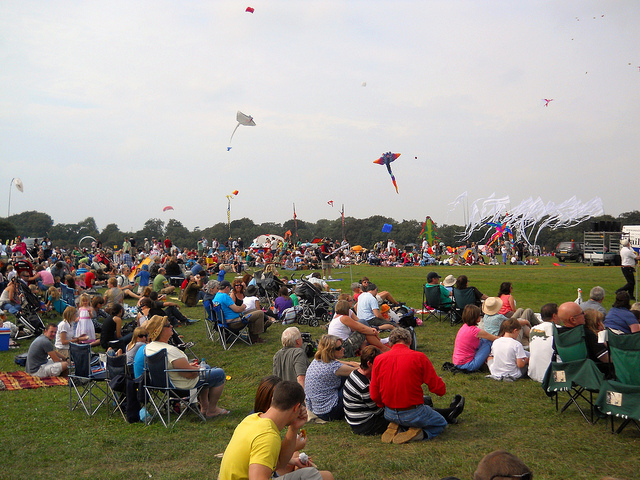Why are there more people than kites? The reason there are more people than kites in the image is likely that this gathering is not just about flying kites but also about community and socialization. People may be taking turns flying the kites, or they simply enjoy watching others do so, which aligns mostly with option C 'mostly spectators'. 